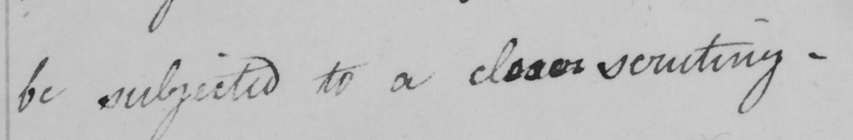What text is written in this handwritten line? be subjected to a closer scrutiny .  _ 